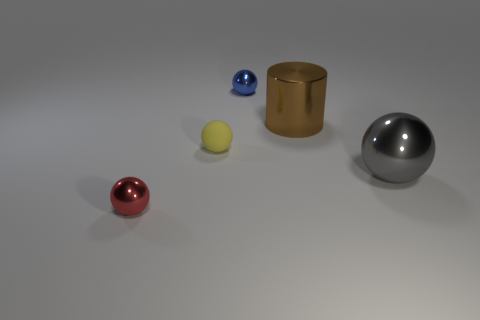Is there any other thing that has the same material as the tiny yellow sphere?
Keep it short and to the point. No. The big brown object that is the same material as the small blue object is what shape?
Provide a succinct answer. Cylinder. What number of shiny objects are big brown cylinders or blue spheres?
Offer a terse response. 2. Are there the same number of tiny red shiny spheres in front of the tiny red thing and large gray shiny balls?
Keep it short and to the point. No. There is a thing that is in front of the gray metal ball; is its color the same as the big cylinder?
Give a very brief answer. No. There is a small object that is in front of the large cylinder and on the right side of the small red metal ball; what is its material?
Provide a succinct answer. Rubber. Is there a big gray object behind the large metal thing in front of the tiny rubber sphere?
Your answer should be very brief. No. Are the big brown thing and the yellow thing made of the same material?
Offer a very short reply. No. What shape is the thing that is both in front of the small rubber ball and behind the red shiny sphere?
Offer a very short reply. Sphere. There is a shiny thing that is behind the big thing that is behind the gray ball; what is its size?
Provide a short and direct response. Small. 